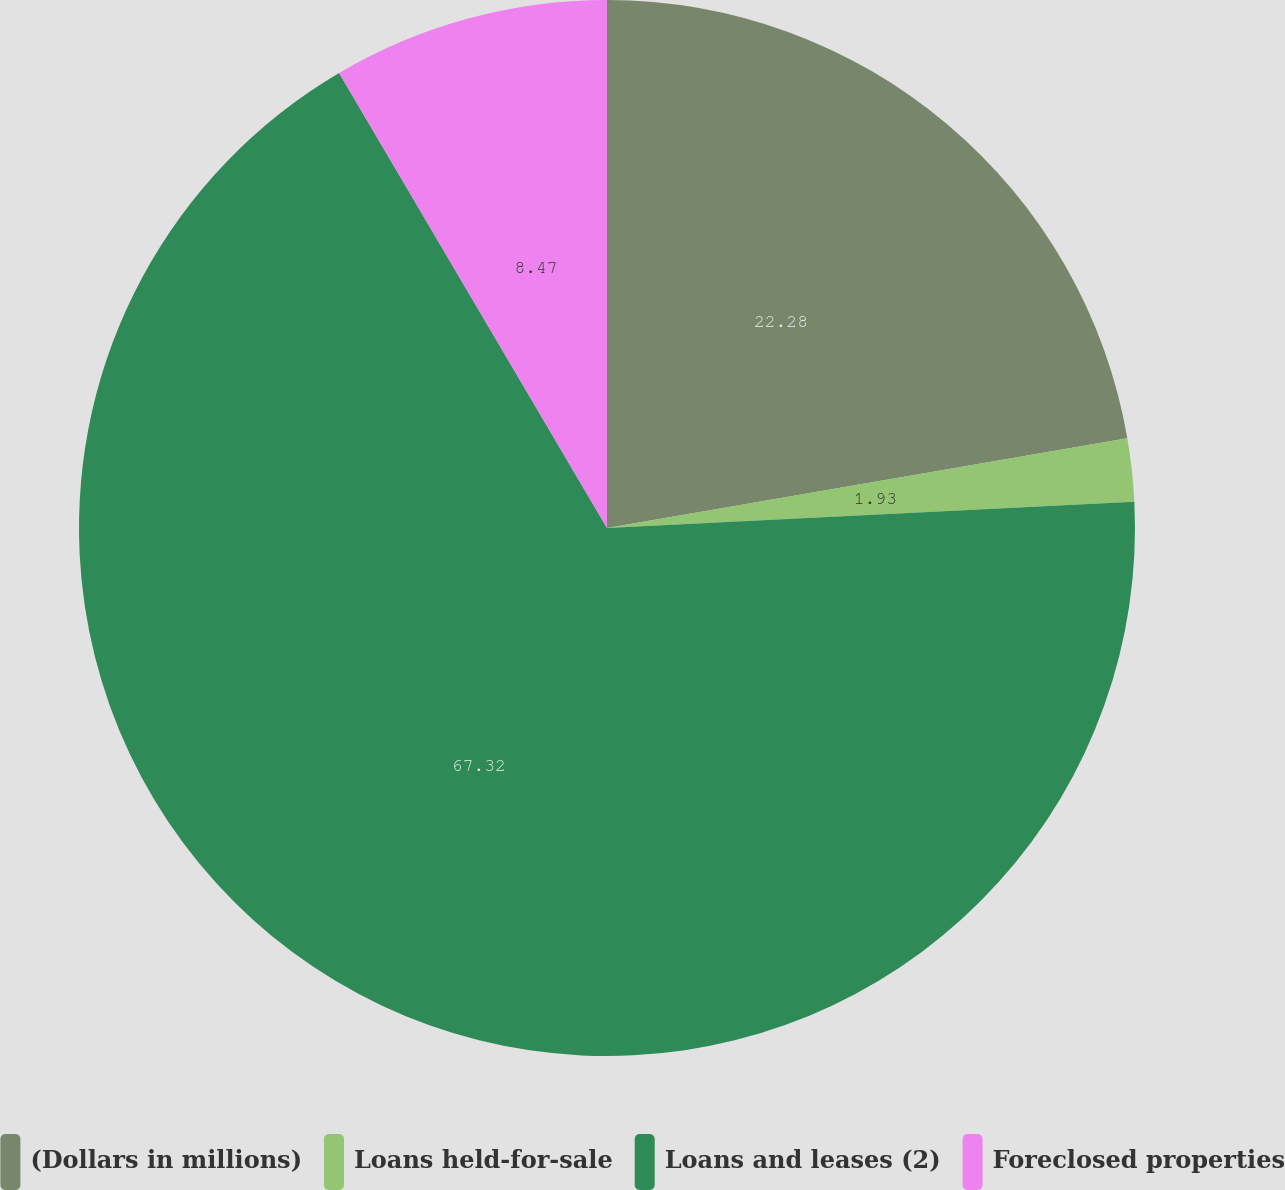Convert chart. <chart><loc_0><loc_0><loc_500><loc_500><pie_chart><fcel>(Dollars in millions)<fcel>Loans held-for-sale<fcel>Loans and leases (2)<fcel>Foreclosed properties<nl><fcel>22.28%<fcel>1.93%<fcel>67.32%<fcel>8.47%<nl></chart> 